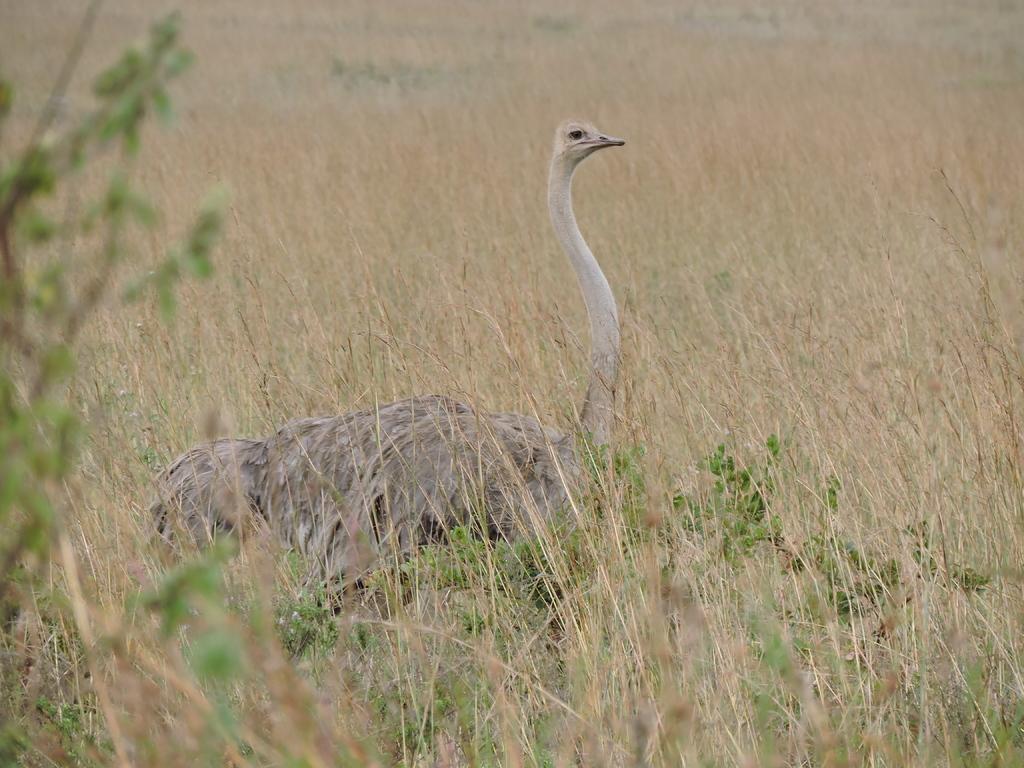Please provide a concise description of this image. In this picture we can see one ostrich standing on the grass. 